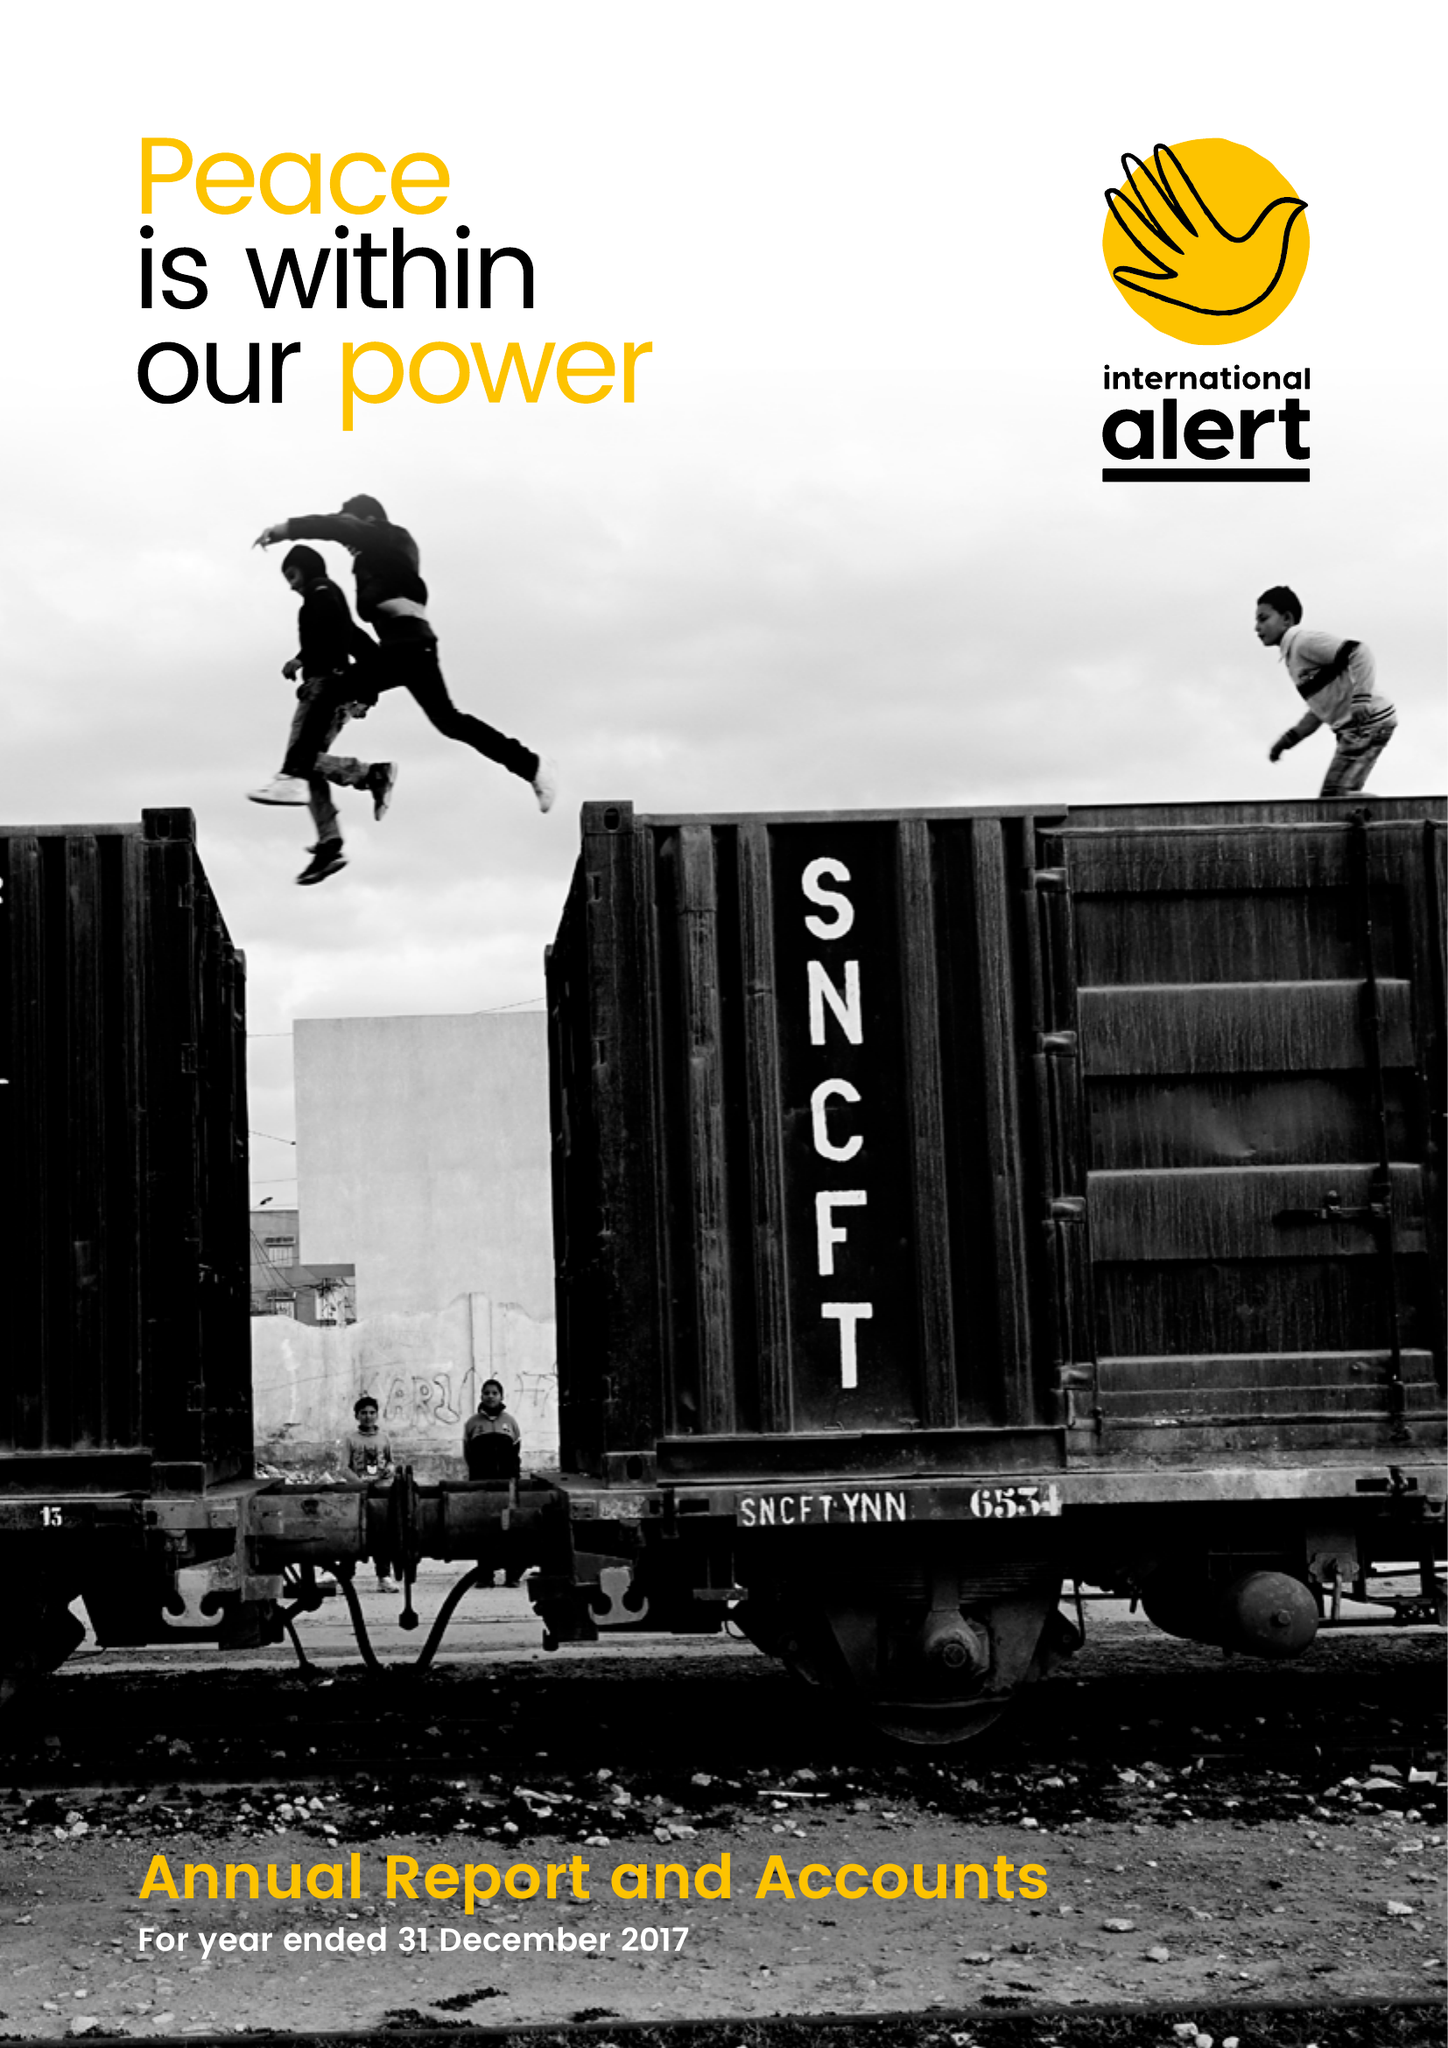What is the value for the income_annually_in_british_pounds?
Answer the question using a single word or phrase. 15906000.00 